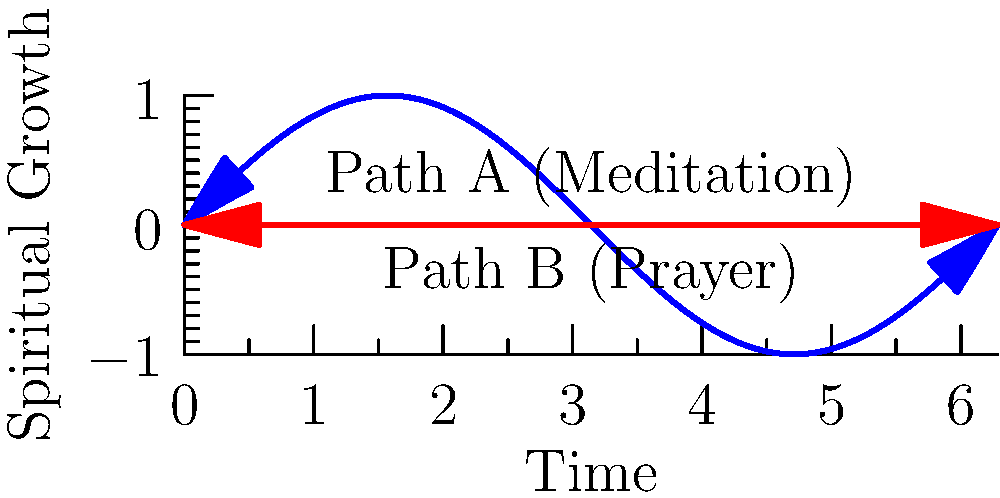Consider two spiritual practices represented by paths in the naval setting: Path A (Meditation) and Path B (Prayer). Are these paths homotopy equivalent in the given space-time representation? To determine if the two paths are homotopy equivalent, we need to follow these steps:

1. Understand the concept of homotopy equivalence:
   Two paths are homotopy equivalent if one can be continuously deformed into the other without leaving the space.

2. Analyze the given paths:
   Path A (Meditation) is represented by a sinusoidal curve.
   Path B (Prayer) is represented by a straight line.

3. Consider the space:
   The space is a 2D plane representing time and spiritual growth.

4. Examine the endpoints:
   Both paths have the same starting point (0,0) and ending point (2π,0).

5. Check for obstacles:
   There are no obstacles or holes in the space that would prevent continuous deformation.

6. Continuous deformation:
   We can imagine gradually "flattening" the sinusoidal curve of Path A to the straight line of Path B without leaving the plane.

7. Reversibility:
   The deformation process can be reversed, transforming Path B into Path A.

Given these considerations, we can conclude that the two paths are indeed homotopy equivalent in this representation.
Answer: Yes, homotopy equivalent. 